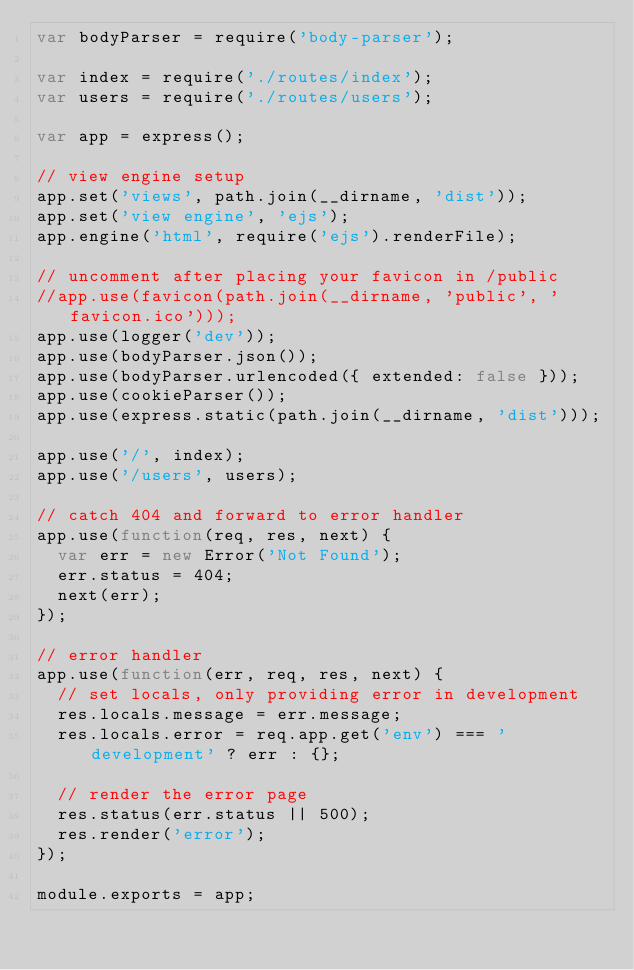Convert code to text. <code><loc_0><loc_0><loc_500><loc_500><_JavaScript_>var bodyParser = require('body-parser');

var index = require('./routes/index');
var users = require('./routes/users');

var app = express();

// view engine setup
app.set('views', path.join(__dirname, 'dist'));
app.set('view engine', 'ejs');
app.engine('html', require('ejs').renderFile);

// uncomment after placing your favicon in /public
//app.use(favicon(path.join(__dirname, 'public', 'favicon.ico')));
app.use(logger('dev'));
app.use(bodyParser.json());
app.use(bodyParser.urlencoded({ extended: false }));
app.use(cookieParser());
app.use(express.static(path.join(__dirname, 'dist')));

app.use('/', index);
app.use('/users', users);

// catch 404 and forward to error handler
app.use(function(req, res, next) {
  var err = new Error('Not Found');
  err.status = 404;
  next(err);
});

// error handler
app.use(function(err, req, res, next) {
  // set locals, only providing error in development
  res.locals.message = err.message;
  res.locals.error = req.app.get('env') === 'development' ? err : {};

  // render the error page
  res.status(err.status || 500);
  res.render('error');
});

module.exports = app;
</code> 